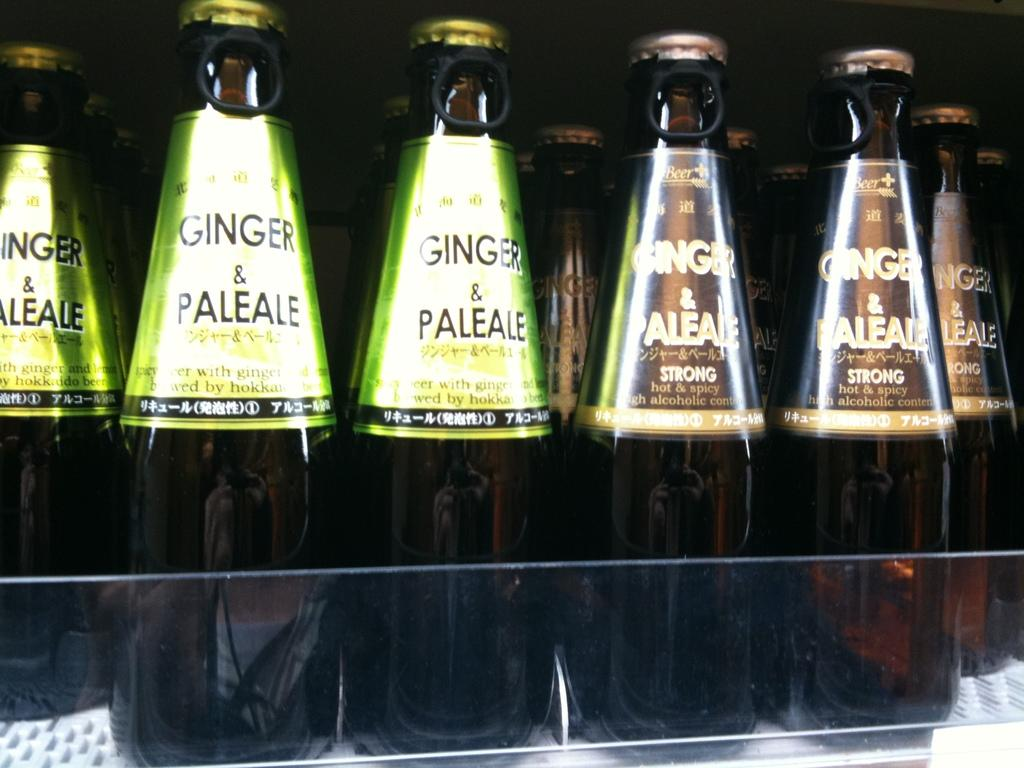<image>
Relay a brief, clear account of the picture shown. Two different kinds of Ginger and Pale Ale are shelved in a store. 